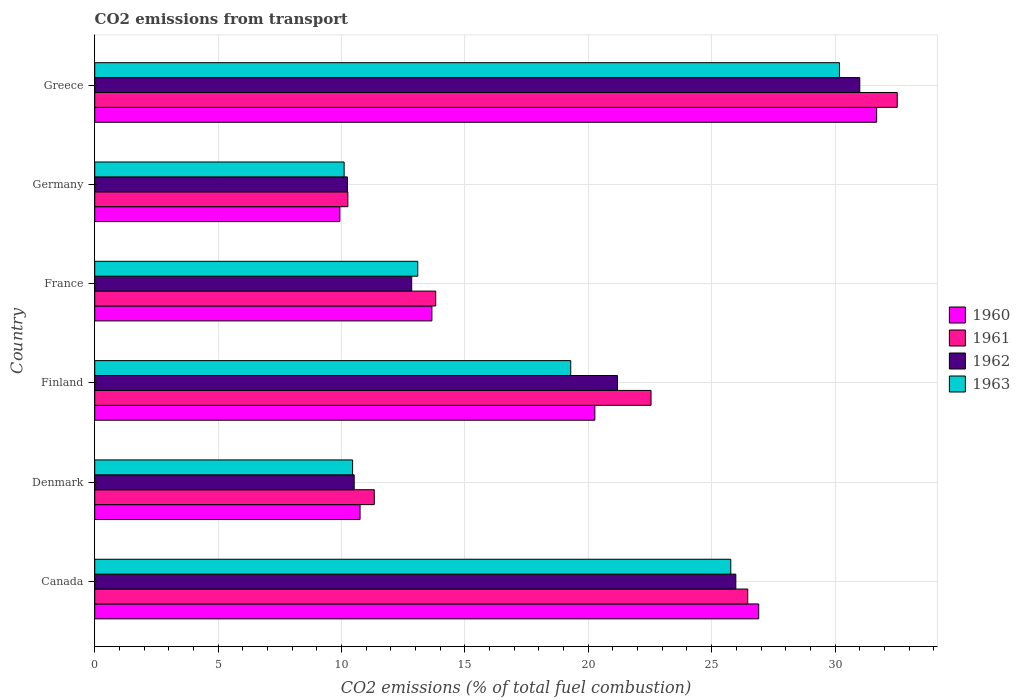How many groups of bars are there?
Your answer should be compact. 6. Are the number of bars per tick equal to the number of legend labels?
Make the answer very short. Yes. How many bars are there on the 6th tick from the top?
Keep it short and to the point. 4. How many bars are there on the 5th tick from the bottom?
Provide a short and direct response. 4. What is the label of the 5th group of bars from the top?
Your answer should be very brief. Denmark. In how many cases, is the number of bars for a given country not equal to the number of legend labels?
Keep it short and to the point. 0. What is the total CO2 emitted in 1962 in France?
Provide a succinct answer. 12.84. Across all countries, what is the maximum total CO2 emitted in 1960?
Provide a succinct answer. 31.69. Across all countries, what is the minimum total CO2 emitted in 1963?
Ensure brevity in your answer.  10.11. In which country was the total CO2 emitted in 1960 maximum?
Offer a very short reply. Greece. In which country was the total CO2 emitted in 1963 minimum?
Provide a short and direct response. Germany. What is the total total CO2 emitted in 1961 in the graph?
Provide a succinct answer. 116.93. What is the difference between the total CO2 emitted in 1963 in France and that in Germany?
Your answer should be very brief. 2.98. What is the difference between the total CO2 emitted in 1963 in France and the total CO2 emitted in 1960 in Denmark?
Make the answer very short. 2.34. What is the average total CO2 emitted in 1963 per country?
Make the answer very short. 18.15. What is the difference between the total CO2 emitted in 1961 and total CO2 emitted in 1960 in Finland?
Your answer should be very brief. 2.28. What is the ratio of the total CO2 emitted in 1963 in Denmark to that in France?
Give a very brief answer. 0.8. Is the total CO2 emitted in 1960 in Finland less than that in Germany?
Ensure brevity in your answer.  No. Is the difference between the total CO2 emitted in 1961 in Denmark and Finland greater than the difference between the total CO2 emitted in 1960 in Denmark and Finland?
Offer a terse response. No. What is the difference between the highest and the second highest total CO2 emitted in 1960?
Offer a terse response. 4.78. What is the difference between the highest and the lowest total CO2 emitted in 1963?
Provide a succinct answer. 20.07. Is it the case that in every country, the sum of the total CO2 emitted in 1963 and total CO2 emitted in 1961 is greater than the total CO2 emitted in 1960?
Your answer should be very brief. Yes. How many bars are there?
Your answer should be compact. 24. Are all the bars in the graph horizontal?
Your response must be concise. Yes. Are the values on the major ticks of X-axis written in scientific E-notation?
Your answer should be compact. No. Does the graph contain any zero values?
Provide a succinct answer. No. Does the graph contain grids?
Offer a terse response. Yes. Where does the legend appear in the graph?
Keep it short and to the point. Center right. How many legend labels are there?
Provide a short and direct response. 4. How are the legend labels stacked?
Give a very brief answer. Vertical. What is the title of the graph?
Your answer should be very brief. CO2 emissions from transport. Does "1982" appear as one of the legend labels in the graph?
Give a very brief answer. No. What is the label or title of the X-axis?
Offer a very short reply. CO2 emissions (% of total fuel combustion). What is the label or title of the Y-axis?
Give a very brief answer. Country. What is the CO2 emissions (% of total fuel combustion) in 1960 in Canada?
Offer a terse response. 26.91. What is the CO2 emissions (% of total fuel combustion) of 1961 in Canada?
Your response must be concise. 26.46. What is the CO2 emissions (% of total fuel combustion) in 1962 in Canada?
Offer a very short reply. 25.98. What is the CO2 emissions (% of total fuel combustion) of 1963 in Canada?
Give a very brief answer. 25.78. What is the CO2 emissions (% of total fuel combustion) of 1960 in Denmark?
Offer a very short reply. 10.75. What is the CO2 emissions (% of total fuel combustion) in 1961 in Denmark?
Offer a terse response. 11.33. What is the CO2 emissions (% of total fuel combustion) in 1962 in Denmark?
Ensure brevity in your answer.  10.51. What is the CO2 emissions (% of total fuel combustion) in 1963 in Denmark?
Your answer should be very brief. 10.45. What is the CO2 emissions (% of total fuel combustion) of 1960 in Finland?
Provide a succinct answer. 20.27. What is the CO2 emissions (% of total fuel combustion) of 1961 in Finland?
Your answer should be very brief. 22.54. What is the CO2 emissions (% of total fuel combustion) of 1962 in Finland?
Offer a very short reply. 21.18. What is the CO2 emissions (% of total fuel combustion) of 1963 in Finland?
Offer a terse response. 19.29. What is the CO2 emissions (% of total fuel combustion) in 1960 in France?
Your response must be concise. 13.66. What is the CO2 emissions (% of total fuel combustion) of 1961 in France?
Your answer should be compact. 13.82. What is the CO2 emissions (% of total fuel combustion) in 1962 in France?
Keep it short and to the point. 12.84. What is the CO2 emissions (% of total fuel combustion) in 1963 in France?
Your response must be concise. 13.09. What is the CO2 emissions (% of total fuel combustion) of 1960 in Germany?
Ensure brevity in your answer.  9.93. What is the CO2 emissions (% of total fuel combustion) of 1961 in Germany?
Provide a short and direct response. 10.26. What is the CO2 emissions (% of total fuel combustion) of 1962 in Germany?
Offer a very short reply. 10.24. What is the CO2 emissions (% of total fuel combustion) of 1963 in Germany?
Offer a terse response. 10.11. What is the CO2 emissions (% of total fuel combustion) in 1960 in Greece?
Keep it short and to the point. 31.69. What is the CO2 emissions (% of total fuel combustion) in 1961 in Greece?
Provide a short and direct response. 32.52. What is the CO2 emissions (% of total fuel combustion) in 1962 in Greece?
Make the answer very short. 31. What is the CO2 emissions (% of total fuel combustion) of 1963 in Greece?
Give a very brief answer. 30.18. Across all countries, what is the maximum CO2 emissions (% of total fuel combustion) of 1960?
Provide a short and direct response. 31.69. Across all countries, what is the maximum CO2 emissions (% of total fuel combustion) in 1961?
Your answer should be very brief. 32.52. Across all countries, what is the maximum CO2 emissions (% of total fuel combustion) of 1962?
Provide a succinct answer. 31. Across all countries, what is the maximum CO2 emissions (% of total fuel combustion) in 1963?
Offer a very short reply. 30.18. Across all countries, what is the minimum CO2 emissions (% of total fuel combustion) of 1960?
Provide a succinct answer. 9.93. Across all countries, what is the minimum CO2 emissions (% of total fuel combustion) of 1961?
Provide a short and direct response. 10.26. Across all countries, what is the minimum CO2 emissions (% of total fuel combustion) of 1962?
Ensure brevity in your answer.  10.24. Across all countries, what is the minimum CO2 emissions (% of total fuel combustion) of 1963?
Provide a short and direct response. 10.11. What is the total CO2 emissions (% of total fuel combustion) in 1960 in the graph?
Your answer should be very brief. 113.21. What is the total CO2 emissions (% of total fuel combustion) of 1961 in the graph?
Offer a terse response. 116.93. What is the total CO2 emissions (% of total fuel combustion) of 1962 in the graph?
Provide a succinct answer. 111.76. What is the total CO2 emissions (% of total fuel combustion) of 1963 in the graph?
Your answer should be compact. 108.89. What is the difference between the CO2 emissions (% of total fuel combustion) in 1960 in Canada and that in Denmark?
Offer a terse response. 16.16. What is the difference between the CO2 emissions (% of total fuel combustion) in 1961 in Canada and that in Denmark?
Your answer should be compact. 15.13. What is the difference between the CO2 emissions (% of total fuel combustion) in 1962 in Canada and that in Denmark?
Your response must be concise. 15.47. What is the difference between the CO2 emissions (% of total fuel combustion) of 1963 in Canada and that in Denmark?
Your answer should be compact. 15.33. What is the difference between the CO2 emissions (% of total fuel combustion) of 1960 in Canada and that in Finland?
Give a very brief answer. 6.64. What is the difference between the CO2 emissions (% of total fuel combustion) of 1961 in Canada and that in Finland?
Give a very brief answer. 3.92. What is the difference between the CO2 emissions (% of total fuel combustion) in 1962 in Canada and that in Finland?
Offer a very short reply. 4.8. What is the difference between the CO2 emissions (% of total fuel combustion) of 1963 in Canada and that in Finland?
Ensure brevity in your answer.  6.49. What is the difference between the CO2 emissions (% of total fuel combustion) in 1960 in Canada and that in France?
Offer a terse response. 13.24. What is the difference between the CO2 emissions (% of total fuel combustion) in 1961 in Canada and that in France?
Provide a succinct answer. 12.64. What is the difference between the CO2 emissions (% of total fuel combustion) in 1962 in Canada and that in France?
Keep it short and to the point. 13.14. What is the difference between the CO2 emissions (% of total fuel combustion) of 1963 in Canada and that in France?
Make the answer very short. 12.68. What is the difference between the CO2 emissions (% of total fuel combustion) in 1960 in Canada and that in Germany?
Give a very brief answer. 16.97. What is the difference between the CO2 emissions (% of total fuel combustion) of 1961 in Canada and that in Germany?
Offer a terse response. 16.21. What is the difference between the CO2 emissions (% of total fuel combustion) of 1962 in Canada and that in Germany?
Provide a succinct answer. 15.74. What is the difference between the CO2 emissions (% of total fuel combustion) in 1963 in Canada and that in Germany?
Offer a terse response. 15.67. What is the difference between the CO2 emissions (% of total fuel combustion) in 1960 in Canada and that in Greece?
Give a very brief answer. -4.78. What is the difference between the CO2 emissions (% of total fuel combustion) of 1961 in Canada and that in Greece?
Offer a very short reply. -6.06. What is the difference between the CO2 emissions (% of total fuel combustion) in 1962 in Canada and that in Greece?
Your answer should be compact. -5.02. What is the difference between the CO2 emissions (% of total fuel combustion) in 1963 in Canada and that in Greece?
Your answer should be very brief. -4.4. What is the difference between the CO2 emissions (% of total fuel combustion) of 1960 in Denmark and that in Finland?
Your answer should be very brief. -9.51. What is the difference between the CO2 emissions (% of total fuel combustion) of 1961 in Denmark and that in Finland?
Keep it short and to the point. -11.22. What is the difference between the CO2 emissions (% of total fuel combustion) in 1962 in Denmark and that in Finland?
Ensure brevity in your answer.  -10.67. What is the difference between the CO2 emissions (% of total fuel combustion) of 1963 in Denmark and that in Finland?
Make the answer very short. -8.84. What is the difference between the CO2 emissions (% of total fuel combustion) of 1960 in Denmark and that in France?
Give a very brief answer. -2.91. What is the difference between the CO2 emissions (% of total fuel combustion) in 1961 in Denmark and that in France?
Keep it short and to the point. -2.49. What is the difference between the CO2 emissions (% of total fuel combustion) of 1962 in Denmark and that in France?
Ensure brevity in your answer.  -2.33. What is the difference between the CO2 emissions (% of total fuel combustion) in 1963 in Denmark and that in France?
Your response must be concise. -2.64. What is the difference between the CO2 emissions (% of total fuel combustion) in 1960 in Denmark and that in Germany?
Give a very brief answer. 0.82. What is the difference between the CO2 emissions (% of total fuel combustion) in 1961 in Denmark and that in Germany?
Offer a very short reply. 1.07. What is the difference between the CO2 emissions (% of total fuel combustion) in 1962 in Denmark and that in Germany?
Give a very brief answer. 0.28. What is the difference between the CO2 emissions (% of total fuel combustion) in 1963 in Denmark and that in Germany?
Your answer should be very brief. 0.34. What is the difference between the CO2 emissions (% of total fuel combustion) of 1960 in Denmark and that in Greece?
Provide a short and direct response. -20.93. What is the difference between the CO2 emissions (% of total fuel combustion) of 1961 in Denmark and that in Greece?
Your answer should be compact. -21.19. What is the difference between the CO2 emissions (% of total fuel combustion) in 1962 in Denmark and that in Greece?
Offer a very short reply. -20.49. What is the difference between the CO2 emissions (% of total fuel combustion) of 1963 in Denmark and that in Greece?
Ensure brevity in your answer.  -19.73. What is the difference between the CO2 emissions (% of total fuel combustion) in 1960 in Finland and that in France?
Keep it short and to the point. 6.6. What is the difference between the CO2 emissions (% of total fuel combustion) in 1961 in Finland and that in France?
Offer a terse response. 8.73. What is the difference between the CO2 emissions (% of total fuel combustion) in 1962 in Finland and that in France?
Your answer should be very brief. 8.34. What is the difference between the CO2 emissions (% of total fuel combustion) in 1963 in Finland and that in France?
Offer a terse response. 6.2. What is the difference between the CO2 emissions (% of total fuel combustion) in 1960 in Finland and that in Germany?
Provide a succinct answer. 10.33. What is the difference between the CO2 emissions (% of total fuel combustion) of 1961 in Finland and that in Germany?
Your answer should be very brief. 12.29. What is the difference between the CO2 emissions (% of total fuel combustion) of 1962 in Finland and that in Germany?
Ensure brevity in your answer.  10.94. What is the difference between the CO2 emissions (% of total fuel combustion) in 1963 in Finland and that in Germany?
Provide a short and direct response. 9.18. What is the difference between the CO2 emissions (% of total fuel combustion) in 1960 in Finland and that in Greece?
Your answer should be compact. -11.42. What is the difference between the CO2 emissions (% of total fuel combustion) of 1961 in Finland and that in Greece?
Give a very brief answer. -9.98. What is the difference between the CO2 emissions (% of total fuel combustion) in 1962 in Finland and that in Greece?
Make the answer very short. -9.82. What is the difference between the CO2 emissions (% of total fuel combustion) of 1963 in Finland and that in Greece?
Offer a terse response. -10.89. What is the difference between the CO2 emissions (% of total fuel combustion) in 1960 in France and that in Germany?
Offer a terse response. 3.73. What is the difference between the CO2 emissions (% of total fuel combustion) of 1961 in France and that in Germany?
Your answer should be very brief. 3.56. What is the difference between the CO2 emissions (% of total fuel combustion) of 1962 in France and that in Germany?
Make the answer very short. 2.6. What is the difference between the CO2 emissions (% of total fuel combustion) in 1963 in France and that in Germany?
Offer a very short reply. 2.98. What is the difference between the CO2 emissions (% of total fuel combustion) in 1960 in France and that in Greece?
Give a very brief answer. -18.02. What is the difference between the CO2 emissions (% of total fuel combustion) in 1961 in France and that in Greece?
Keep it short and to the point. -18.7. What is the difference between the CO2 emissions (% of total fuel combustion) in 1962 in France and that in Greece?
Make the answer very short. -18.16. What is the difference between the CO2 emissions (% of total fuel combustion) in 1963 in France and that in Greece?
Provide a succinct answer. -17.09. What is the difference between the CO2 emissions (% of total fuel combustion) of 1960 in Germany and that in Greece?
Offer a very short reply. -21.75. What is the difference between the CO2 emissions (% of total fuel combustion) of 1961 in Germany and that in Greece?
Your answer should be very brief. -22.26. What is the difference between the CO2 emissions (% of total fuel combustion) in 1962 in Germany and that in Greece?
Keep it short and to the point. -20.76. What is the difference between the CO2 emissions (% of total fuel combustion) in 1963 in Germany and that in Greece?
Provide a succinct answer. -20.07. What is the difference between the CO2 emissions (% of total fuel combustion) of 1960 in Canada and the CO2 emissions (% of total fuel combustion) of 1961 in Denmark?
Offer a very short reply. 15.58. What is the difference between the CO2 emissions (% of total fuel combustion) of 1960 in Canada and the CO2 emissions (% of total fuel combustion) of 1962 in Denmark?
Make the answer very short. 16.39. What is the difference between the CO2 emissions (% of total fuel combustion) in 1960 in Canada and the CO2 emissions (% of total fuel combustion) in 1963 in Denmark?
Your response must be concise. 16.46. What is the difference between the CO2 emissions (% of total fuel combustion) in 1961 in Canada and the CO2 emissions (% of total fuel combustion) in 1962 in Denmark?
Your answer should be very brief. 15.95. What is the difference between the CO2 emissions (% of total fuel combustion) of 1961 in Canada and the CO2 emissions (% of total fuel combustion) of 1963 in Denmark?
Make the answer very short. 16.01. What is the difference between the CO2 emissions (% of total fuel combustion) of 1962 in Canada and the CO2 emissions (% of total fuel combustion) of 1963 in Denmark?
Your response must be concise. 15.53. What is the difference between the CO2 emissions (% of total fuel combustion) in 1960 in Canada and the CO2 emissions (% of total fuel combustion) in 1961 in Finland?
Your response must be concise. 4.36. What is the difference between the CO2 emissions (% of total fuel combustion) in 1960 in Canada and the CO2 emissions (% of total fuel combustion) in 1962 in Finland?
Keep it short and to the point. 5.73. What is the difference between the CO2 emissions (% of total fuel combustion) in 1960 in Canada and the CO2 emissions (% of total fuel combustion) in 1963 in Finland?
Give a very brief answer. 7.62. What is the difference between the CO2 emissions (% of total fuel combustion) in 1961 in Canada and the CO2 emissions (% of total fuel combustion) in 1962 in Finland?
Your answer should be compact. 5.28. What is the difference between the CO2 emissions (% of total fuel combustion) in 1961 in Canada and the CO2 emissions (% of total fuel combustion) in 1963 in Finland?
Provide a short and direct response. 7.17. What is the difference between the CO2 emissions (% of total fuel combustion) in 1962 in Canada and the CO2 emissions (% of total fuel combustion) in 1963 in Finland?
Make the answer very short. 6.69. What is the difference between the CO2 emissions (% of total fuel combustion) of 1960 in Canada and the CO2 emissions (% of total fuel combustion) of 1961 in France?
Give a very brief answer. 13.09. What is the difference between the CO2 emissions (% of total fuel combustion) in 1960 in Canada and the CO2 emissions (% of total fuel combustion) in 1962 in France?
Make the answer very short. 14.06. What is the difference between the CO2 emissions (% of total fuel combustion) of 1960 in Canada and the CO2 emissions (% of total fuel combustion) of 1963 in France?
Your response must be concise. 13.82. What is the difference between the CO2 emissions (% of total fuel combustion) of 1961 in Canada and the CO2 emissions (% of total fuel combustion) of 1962 in France?
Offer a terse response. 13.62. What is the difference between the CO2 emissions (% of total fuel combustion) of 1961 in Canada and the CO2 emissions (% of total fuel combustion) of 1963 in France?
Give a very brief answer. 13.37. What is the difference between the CO2 emissions (% of total fuel combustion) of 1962 in Canada and the CO2 emissions (% of total fuel combustion) of 1963 in France?
Keep it short and to the point. 12.89. What is the difference between the CO2 emissions (% of total fuel combustion) of 1960 in Canada and the CO2 emissions (% of total fuel combustion) of 1961 in Germany?
Offer a very short reply. 16.65. What is the difference between the CO2 emissions (% of total fuel combustion) of 1960 in Canada and the CO2 emissions (% of total fuel combustion) of 1962 in Germany?
Your answer should be very brief. 16.67. What is the difference between the CO2 emissions (% of total fuel combustion) in 1960 in Canada and the CO2 emissions (% of total fuel combustion) in 1963 in Germany?
Keep it short and to the point. 16.8. What is the difference between the CO2 emissions (% of total fuel combustion) in 1961 in Canada and the CO2 emissions (% of total fuel combustion) in 1962 in Germany?
Give a very brief answer. 16.22. What is the difference between the CO2 emissions (% of total fuel combustion) in 1961 in Canada and the CO2 emissions (% of total fuel combustion) in 1963 in Germany?
Provide a succinct answer. 16.36. What is the difference between the CO2 emissions (% of total fuel combustion) in 1962 in Canada and the CO2 emissions (% of total fuel combustion) in 1963 in Germany?
Keep it short and to the point. 15.87. What is the difference between the CO2 emissions (% of total fuel combustion) in 1960 in Canada and the CO2 emissions (% of total fuel combustion) in 1961 in Greece?
Your answer should be compact. -5.61. What is the difference between the CO2 emissions (% of total fuel combustion) in 1960 in Canada and the CO2 emissions (% of total fuel combustion) in 1962 in Greece?
Offer a very short reply. -4.1. What is the difference between the CO2 emissions (% of total fuel combustion) in 1960 in Canada and the CO2 emissions (% of total fuel combustion) in 1963 in Greece?
Ensure brevity in your answer.  -3.27. What is the difference between the CO2 emissions (% of total fuel combustion) of 1961 in Canada and the CO2 emissions (% of total fuel combustion) of 1962 in Greece?
Ensure brevity in your answer.  -4.54. What is the difference between the CO2 emissions (% of total fuel combustion) of 1961 in Canada and the CO2 emissions (% of total fuel combustion) of 1963 in Greece?
Your answer should be compact. -3.72. What is the difference between the CO2 emissions (% of total fuel combustion) in 1962 in Canada and the CO2 emissions (% of total fuel combustion) in 1963 in Greece?
Your response must be concise. -4.2. What is the difference between the CO2 emissions (% of total fuel combustion) of 1960 in Denmark and the CO2 emissions (% of total fuel combustion) of 1961 in Finland?
Offer a very short reply. -11.79. What is the difference between the CO2 emissions (% of total fuel combustion) in 1960 in Denmark and the CO2 emissions (% of total fuel combustion) in 1962 in Finland?
Your response must be concise. -10.43. What is the difference between the CO2 emissions (% of total fuel combustion) in 1960 in Denmark and the CO2 emissions (% of total fuel combustion) in 1963 in Finland?
Provide a succinct answer. -8.54. What is the difference between the CO2 emissions (% of total fuel combustion) in 1961 in Denmark and the CO2 emissions (% of total fuel combustion) in 1962 in Finland?
Your answer should be very brief. -9.85. What is the difference between the CO2 emissions (% of total fuel combustion) of 1961 in Denmark and the CO2 emissions (% of total fuel combustion) of 1963 in Finland?
Ensure brevity in your answer.  -7.96. What is the difference between the CO2 emissions (% of total fuel combustion) in 1962 in Denmark and the CO2 emissions (% of total fuel combustion) in 1963 in Finland?
Your answer should be very brief. -8.78. What is the difference between the CO2 emissions (% of total fuel combustion) of 1960 in Denmark and the CO2 emissions (% of total fuel combustion) of 1961 in France?
Your response must be concise. -3.07. What is the difference between the CO2 emissions (% of total fuel combustion) in 1960 in Denmark and the CO2 emissions (% of total fuel combustion) in 1962 in France?
Provide a succinct answer. -2.09. What is the difference between the CO2 emissions (% of total fuel combustion) of 1960 in Denmark and the CO2 emissions (% of total fuel combustion) of 1963 in France?
Give a very brief answer. -2.34. What is the difference between the CO2 emissions (% of total fuel combustion) in 1961 in Denmark and the CO2 emissions (% of total fuel combustion) in 1962 in France?
Your answer should be compact. -1.52. What is the difference between the CO2 emissions (% of total fuel combustion) of 1961 in Denmark and the CO2 emissions (% of total fuel combustion) of 1963 in France?
Provide a succinct answer. -1.76. What is the difference between the CO2 emissions (% of total fuel combustion) of 1962 in Denmark and the CO2 emissions (% of total fuel combustion) of 1963 in France?
Your answer should be very brief. -2.58. What is the difference between the CO2 emissions (% of total fuel combustion) in 1960 in Denmark and the CO2 emissions (% of total fuel combustion) in 1961 in Germany?
Keep it short and to the point. 0.5. What is the difference between the CO2 emissions (% of total fuel combustion) of 1960 in Denmark and the CO2 emissions (% of total fuel combustion) of 1962 in Germany?
Offer a terse response. 0.51. What is the difference between the CO2 emissions (% of total fuel combustion) in 1960 in Denmark and the CO2 emissions (% of total fuel combustion) in 1963 in Germany?
Offer a terse response. 0.65. What is the difference between the CO2 emissions (% of total fuel combustion) of 1961 in Denmark and the CO2 emissions (% of total fuel combustion) of 1962 in Germany?
Ensure brevity in your answer.  1.09. What is the difference between the CO2 emissions (% of total fuel combustion) of 1961 in Denmark and the CO2 emissions (% of total fuel combustion) of 1963 in Germany?
Give a very brief answer. 1.22. What is the difference between the CO2 emissions (% of total fuel combustion) in 1962 in Denmark and the CO2 emissions (% of total fuel combustion) in 1963 in Germany?
Keep it short and to the point. 0.41. What is the difference between the CO2 emissions (% of total fuel combustion) in 1960 in Denmark and the CO2 emissions (% of total fuel combustion) in 1961 in Greece?
Offer a very short reply. -21.77. What is the difference between the CO2 emissions (% of total fuel combustion) in 1960 in Denmark and the CO2 emissions (% of total fuel combustion) in 1962 in Greece?
Keep it short and to the point. -20.25. What is the difference between the CO2 emissions (% of total fuel combustion) of 1960 in Denmark and the CO2 emissions (% of total fuel combustion) of 1963 in Greece?
Your answer should be very brief. -19.43. What is the difference between the CO2 emissions (% of total fuel combustion) of 1961 in Denmark and the CO2 emissions (% of total fuel combustion) of 1962 in Greece?
Give a very brief answer. -19.67. What is the difference between the CO2 emissions (% of total fuel combustion) in 1961 in Denmark and the CO2 emissions (% of total fuel combustion) in 1963 in Greece?
Make the answer very short. -18.85. What is the difference between the CO2 emissions (% of total fuel combustion) in 1962 in Denmark and the CO2 emissions (% of total fuel combustion) in 1963 in Greece?
Your response must be concise. -19.66. What is the difference between the CO2 emissions (% of total fuel combustion) in 1960 in Finland and the CO2 emissions (% of total fuel combustion) in 1961 in France?
Ensure brevity in your answer.  6.45. What is the difference between the CO2 emissions (% of total fuel combustion) of 1960 in Finland and the CO2 emissions (% of total fuel combustion) of 1962 in France?
Offer a terse response. 7.42. What is the difference between the CO2 emissions (% of total fuel combustion) of 1960 in Finland and the CO2 emissions (% of total fuel combustion) of 1963 in France?
Your answer should be very brief. 7.18. What is the difference between the CO2 emissions (% of total fuel combustion) of 1961 in Finland and the CO2 emissions (% of total fuel combustion) of 1962 in France?
Offer a terse response. 9.7. What is the difference between the CO2 emissions (% of total fuel combustion) in 1961 in Finland and the CO2 emissions (% of total fuel combustion) in 1963 in France?
Your response must be concise. 9.45. What is the difference between the CO2 emissions (% of total fuel combustion) of 1962 in Finland and the CO2 emissions (% of total fuel combustion) of 1963 in France?
Offer a very short reply. 8.09. What is the difference between the CO2 emissions (% of total fuel combustion) of 1960 in Finland and the CO2 emissions (% of total fuel combustion) of 1961 in Germany?
Offer a terse response. 10.01. What is the difference between the CO2 emissions (% of total fuel combustion) in 1960 in Finland and the CO2 emissions (% of total fuel combustion) in 1962 in Germany?
Ensure brevity in your answer.  10.03. What is the difference between the CO2 emissions (% of total fuel combustion) of 1960 in Finland and the CO2 emissions (% of total fuel combustion) of 1963 in Germany?
Offer a very short reply. 10.16. What is the difference between the CO2 emissions (% of total fuel combustion) of 1961 in Finland and the CO2 emissions (% of total fuel combustion) of 1962 in Germany?
Give a very brief answer. 12.3. What is the difference between the CO2 emissions (% of total fuel combustion) in 1961 in Finland and the CO2 emissions (% of total fuel combustion) in 1963 in Germany?
Provide a short and direct response. 12.44. What is the difference between the CO2 emissions (% of total fuel combustion) in 1962 in Finland and the CO2 emissions (% of total fuel combustion) in 1963 in Germany?
Give a very brief answer. 11.07. What is the difference between the CO2 emissions (% of total fuel combustion) of 1960 in Finland and the CO2 emissions (% of total fuel combustion) of 1961 in Greece?
Your answer should be compact. -12.25. What is the difference between the CO2 emissions (% of total fuel combustion) of 1960 in Finland and the CO2 emissions (% of total fuel combustion) of 1962 in Greece?
Provide a short and direct response. -10.74. What is the difference between the CO2 emissions (% of total fuel combustion) in 1960 in Finland and the CO2 emissions (% of total fuel combustion) in 1963 in Greece?
Offer a very short reply. -9.91. What is the difference between the CO2 emissions (% of total fuel combustion) in 1961 in Finland and the CO2 emissions (% of total fuel combustion) in 1962 in Greece?
Your answer should be very brief. -8.46. What is the difference between the CO2 emissions (% of total fuel combustion) of 1961 in Finland and the CO2 emissions (% of total fuel combustion) of 1963 in Greece?
Your response must be concise. -7.63. What is the difference between the CO2 emissions (% of total fuel combustion) in 1962 in Finland and the CO2 emissions (% of total fuel combustion) in 1963 in Greece?
Your answer should be very brief. -9. What is the difference between the CO2 emissions (% of total fuel combustion) in 1960 in France and the CO2 emissions (% of total fuel combustion) in 1961 in Germany?
Provide a succinct answer. 3.41. What is the difference between the CO2 emissions (% of total fuel combustion) of 1960 in France and the CO2 emissions (% of total fuel combustion) of 1962 in Germany?
Offer a terse response. 3.42. What is the difference between the CO2 emissions (% of total fuel combustion) in 1960 in France and the CO2 emissions (% of total fuel combustion) in 1963 in Germany?
Your answer should be very brief. 3.56. What is the difference between the CO2 emissions (% of total fuel combustion) of 1961 in France and the CO2 emissions (% of total fuel combustion) of 1962 in Germany?
Your answer should be very brief. 3.58. What is the difference between the CO2 emissions (% of total fuel combustion) of 1961 in France and the CO2 emissions (% of total fuel combustion) of 1963 in Germany?
Your response must be concise. 3.71. What is the difference between the CO2 emissions (% of total fuel combustion) in 1962 in France and the CO2 emissions (% of total fuel combustion) in 1963 in Germany?
Give a very brief answer. 2.74. What is the difference between the CO2 emissions (% of total fuel combustion) of 1960 in France and the CO2 emissions (% of total fuel combustion) of 1961 in Greece?
Offer a terse response. -18.86. What is the difference between the CO2 emissions (% of total fuel combustion) in 1960 in France and the CO2 emissions (% of total fuel combustion) in 1962 in Greece?
Keep it short and to the point. -17.34. What is the difference between the CO2 emissions (% of total fuel combustion) of 1960 in France and the CO2 emissions (% of total fuel combustion) of 1963 in Greece?
Keep it short and to the point. -16.52. What is the difference between the CO2 emissions (% of total fuel combustion) in 1961 in France and the CO2 emissions (% of total fuel combustion) in 1962 in Greece?
Offer a very short reply. -17.18. What is the difference between the CO2 emissions (% of total fuel combustion) of 1961 in France and the CO2 emissions (% of total fuel combustion) of 1963 in Greece?
Give a very brief answer. -16.36. What is the difference between the CO2 emissions (% of total fuel combustion) of 1962 in France and the CO2 emissions (% of total fuel combustion) of 1963 in Greece?
Keep it short and to the point. -17.33. What is the difference between the CO2 emissions (% of total fuel combustion) in 1960 in Germany and the CO2 emissions (% of total fuel combustion) in 1961 in Greece?
Make the answer very short. -22.59. What is the difference between the CO2 emissions (% of total fuel combustion) of 1960 in Germany and the CO2 emissions (% of total fuel combustion) of 1962 in Greece?
Provide a short and direct response. -21.07. What is the difference between the CO2 emissions (% of total fuel combustion) of 1960 in Germany and the CO2 emissions (% of total fuel combustion) of 1963 in Greece?
Offer a very short reply. -20.24. What is the difference between the CO2 emissions (% of total fuel combustion) in 1961 in Germany and the CO2 emissions (% of total fuel combustion) in 1962 in Greece?
Keep it short and to the point. -20.75. What is the difference between the CO2 emissions (% of total fuel combustion) of 1961 in Germany and the CO2 emissions (% of total fuel combustion) of 1963 in Greece?
Keep it short and to the point. -19.92. What is the difference between the CO2 emissions (% of total fuel combustion) of 1962 in Germany and the CO2 emissions (% of total fuel combustion) of 1963 in Greece?
Your answer should be compact. -19.94. What is the average CO2 emissions (% of total fuel combustion) of 1960 per country?
Offer a terse response. 18.87. What is the average CO2 emissions (% of total fuel combustion) of 1961 per country?
Your answer should be compact. 19.49. What is the average CO2 emissions (% of total fuel combustion) of 1962 per country?
Your answer should be very brief. 18.63. What is the average CO2 emissions (% of total fuel combustion) in 1963 per country?
Ensure brevity in your answer.  18.15. What is the difference between the CO2 emissions (% of total fuel combustion) of 1960 and CO2 emissions (% of total fuel combustion) of 1961 in Canada?
Provide a succinct answer. 0.44. What is the difference between the CO2 emissions (% of total fuel combustion) of 1960 and CO2 emissions (% of total fuel combustion) of 1962 in Canada?
Keep it short and to the point. 0.93. What is the difference between the CO2 emissions (% of total fuel combustion) of 1960 and CO2 emissions (% of total fuel combustion) of 1963 in Canada?
Keep it short and to the point. 1.13. What is the difference between the CO2 emissions (% of total fuel combustion) of 1961 and CO2 emissions (% of total fuel combustion) of 1962 in Canada?
Give a very brief answer. 0.48. What is the difference between the CO2 emissions (% of total fuel combustion) in 1961 and CO2 emissions (% of total fuel combustion) in 1963 in Canada?
Your response must be concise. 0.69. What is the difference between the CO2 emissions (% of total fuel combustion) of 1962 and CO2 emissions (% of total fuel combustion) of 1963 in Canada?
Provide a succinct answer. 0.2. What is the difference between the CO2 emissions (% of total fuel combustion) of 1960 and CO2 emissions (% of total fuel combustion) of 1961 in Denmark?
Make the answer very short. -0.58. What is the difference between the CO2 emissions (% of total fuel combustion) in 1960 and CO2 emissions (% of total fuel combustion) in 1962 in Denmark?
Make the answer very short. 0.24. What is the difference between the CO2 emissions (% of total fuel combustion) in 1960 and CO2 emissions (% of total fuel combustion) in 1963 in Denmark?
Your answer should be very brief. 0.3. What is the difference between the CO2 emissions (% of total fuel combustion) of 1961 and CO2 emissions (% of total fuel combustion) of 1962 in Denmark?
Provide a succinct answer. 0.81. What is the difference between the CO2 emissions (% of total fuel combustion) of 1961 and CO2 emissions (% of total fuel combustion) of 1963 in Denmark?
Keep it short and to the point. 0.88. What is the difference between the CO2 emissions (% of total fuel combustion) of 1962 and CO2 emissions (% of total fuel combustion) of 1963 in Denmark?
Offer a terse response. 0.06. What is the difference between the CO2 emissions (% of total fuel combustion) of 1960 and CO2 emissions (% of total fuel combustion) of 1961 in Finland?
Keep it short and to the point. -2.28. What is the difference between the CO2 emissions (% of total fuel combustion) in 1960 and CO2 emissions (% of total fuel combustion) in 1962 in Finland?
Ensure brevity in your answer.  -0.91. What is the difference between the CO2 emissions (% of total fuel combustion) of 1960 and CO2 emissions (% of total fuel combustion) of 1963 in Finland?
Your response must be concise. 0.98. What is the difference between the CO2 emissions (% of total fuel combustion) of 1961 and CO2 emissions (% of total fuel combustion) of 1962 in Finland?
Make the answer very short. 1.36. What is the difference between the CO2 emissions (% of total fuel combustion) of 1961 and CO2 emissions (% of total fuel combustion) of 1963 in Finland?
Your answer should be compact. 3.25. What is the difference between the CO2 emissions (% of total fuel combustion) in 1962 and CO2 emissions (% of total fuel combustion) in 1963 in Finland?
Provide a short and direct response. 1.89. What is the difference between the CO2 emissions (% of total fuel combustion) in 1960 and CO2 emissions (% of total fuel combustion) in 1961 in France?
Give a very brief answer. -0.16. What is the difference between the CO2 emissions (% of total fuel combustion) of 1960 and CO2 emissions (% of total fuel combustion) of 1962 in France?
Provide a succinct answer. 0.82. What is the difference between the CO2 emissions (% of total fuel combustion) in 1960 and CO2 emissions (% of total fuel combustion) in 1963 in France?
Provide a short and direct response. 0.57. What is the difference between the CO2 emissions (% of total fuel combustion) in 1961 and CO2 emissions (% of total fuel combustion) in 1962 in France?
Provide a short and direct response. 0.97. What is the difference between the CO2 emissions (% of total fuel combustion) of 1961 and CO2 emissions (% of total fuel combustion) of 1963 in France?
Ensure brevity in your answer.  0.73. What is the difference between the CO2 emissions (% of total fuel combustion) of 1962 and CO2 emissions (% of total fuel combustion) of 1963 in France?
Your answer should be compact. -0.25. What is the difference between the CO2 emissions (% of total fuel combustion) of 1960 and CO2 emissions (% of total fuel combustion) of 1961 in Germany?
Offer a terse response. -0.32. What is the difference between the CO2 emissions (% of total fuel combustion) in 1960 and CO2 emissions (% of total fuel combustion) in 1962 in Germany?
Your response must be concise. -0.3. What is the difference between the CO2 emissions (% of total fuel combustion) of 1960 and CO2 emissions (% of total fuel combustion) of 1963 in Germany?
Keep it short and to the point. -0.17. What is the difference between the CO2 emissions (% of total fuel combustion) in 1961 and CO2 emissions (% of total fuel combustion) in 1962 in Germany?
Offer a very short reply. 0.02. What is the difference between the CO2 emissions (% of total fuel combustion) of 1961 and CO2 emissions (% of total fuel combustion) of 1963 in Germany?
Provide a succinct answer. 0.15. What is the difference between the CO2 emissions (% of total fuel combustion) in 1962 and CO2 emissions (% of total fuel combustion) in 1963 in Germany?
Provide a succinct answer. 0.13. What is the difference between the CO2 emissions (% of total fuel combustion) of 1960 and CO2 emissions (% of total fuel combustion) of 1961 in Greece?
Make the answer very short. -0.83. What is the difference between the CO2 emissions (% of total fuel combustion) of 1960 and CO2 emissions (% of total fuel combustion) of 1962 in Greece?
Your answer should be compact. 0.68. What is the difference between the CO2 emissions (% of total fuel combustion) of 1960 and CO2 emissions (% of total fuel combustion) of 1963 in Greece?
Your response must be concise. 1.51. What is the difference between the CO2 emissions (% of total fuel combustion) in 1961 and CO2 emissions (% of total fuel combustion) in 1962 in Greece?
Provide a short and direct response. 1.52. What is the difference between the CO2 emissions (% of total fuel combustion) of 1961 and CO2 emissions (% of total fuel combustion) of 1963 in Greece?
Your answer should be very brief. 2.34. What is the difference between the CO2 emissions (% of total fuel combustion) of 1962 and CO2 emissions (% of total fuel combustion) of 1963 in Greece?
Your answer should be very brief. 0.82. What is the ratio of the CO2 emissions (% of total fuel combustion) in 1960 in Canada to that in Denmark?
Keep it short and to the point. 2.5. What is the ratio of the CO2 emissions (% of total fuel combustion) in 1961 in Canada to that in Denmark?
Give a very brief answer. 2.34. What is the ratio of the CO2 emissions (% of total fuel combustion) in 1962 in Canada to that in Denmark?
Give a very brief answer. 2.47. What is the ratio of the CO2 emissions (% of total fuel combustion) in 1963 in Canada to that in Denmark?
Give a very brief answer. 2.47. What is the ratio of the CO2 emissions (% of total fuel combustion) in 1960 in Canada to that in Finland?
Make the answer very short. 1.33. What is the ratio of the CO2 emissions (% of total fuel combustion) in 1961 in Canada to that in Finland?
Ensure brevity in your answer.  1.17. What is the ratio of the CO2 emissions (% of total fuel combustion) of 1962 in Canada to that in Finland?
Provide a short and direct response. 1.23. What is the ratio of the CO2 emissions (% of total fuel combustion) in 1963 in Canada to that in Finland?
Your answer should be very brief. 1.34. What is the ratio of the CO2 emissions (% of total fuel combustion) of 1960 in Canada to that in France?
Ensure brevity in your answer.  1.97. What is the ratio of the CO2 emissions (% of total fuel combustion) in 1961 in Canada to that in France?
Make the answer very short. 1.92. What is the ratio of the CO2 emissions (% of total fuel combustion) in 1962 in Canada to that in France?
Your answer should be very brief. 2.02. What is the ratio of the CO2 emissions (% of total fuel combustion) of 1963 in Canada to that in France?
Provide a succinct answer. 1.97. What is the ratio of the CO2 emissions (% of total fuel combustion) of 1960 in Canada to that in Germany?
Your answer should be compact. 2.71. What is the ratio of the CO2 emissions (% of total fuel combustion) in 1961 in Canada to that in Germany?
Give a very brief answer. 2.58. What is the ratio of the CO2 emissions (% of total fuel combustion) of 1962 in Canada to that in Germany?
Your answer should be very brief. 2.54. What is the ratio of the CO2 emissions (% of total fuel combustion) of 1963 in Canada to that in Germany?
Give a very brief answer. 2.55. What is the ratio of the CO2 emissions (% of total fuel combustion) in 1960 in Canada to that in Greece?
Offer a very short reply. 0.85. What is the ratio of the CO2 emissions (% of total fuel combustion) in 1961 in Canada to that in Greece?
Your answer should be compact. 0.81. What is the ratio of the CO2 emissions (% of total fuel combustion) in 1962 in Canada to that in Greece?
Keep it short and to the point. 0.84. What is the ratio of the CO2 emissions (% of total fuel combustion) of 1963 in Canada to that in Greece?
Give a very brief answer. 0.85. What is the ratio of the CO2 emissions (% of total fuel combustion) of 1960 in Denmark to that in Finland?
Provide a succinct answer. 0.53. What is the ratio of the CO2 emissions (% of total fuel combustion) in 1961 in Denmark to that in Finland?
Make the answer very short. 0.5. What is the ratio of the CO2 emissions (% of total fuel combustion) of 1962 in Denmark to that in Finland?
Your response must be concise. 0.5. What is the ratio of the CO2 emissions (% of total fuel combustion) of 1963 in Denmark to that in Finland?
Offer a very short reply. 0.54. What is the ratio of the CO2 emissions (% of total fuel combustion) in 1960 in Denmark to that in France?
Offer a very short reply. 0.79. What is the ratio of the CO2 emissions (% of total fuel combustion) in 1961 in Denmark to that in France?
Provide a succinct answer. 0.82. What is the ratio of the CO2 emissions (% of total fuel combustion) of 1962 in Denmark to that in France?
Offer a very short reply. 0.82. What is the ratio of the CO2 emissions (% of total fuel combustion) of 1963 in Denmark to that in France?
Offer a terse response. 0.8. What is the ratio of the CO2 emissions (% of total fuel combustion) in 1960 in Denmark to that in Germany?
Make the answer very short. 1.08. What is the ratio of the CO2 emissions (% of total fuel combustion) of 1961 in Denmark to that in Germany?
Your response must be concise. 1.1. What is the ratio of the CO2 emissions (% of total fuel combustion) in 1962 in Denmark to that in Germany?
Offer a very short reply. 1.03. What is the ratio of the CO2 emissions (% of total fuel combustion) of 1963 in Denmark to that in Germany?
Your response must be concise. 1.03. What is the ratio of the CO2 emissions (% of total fuel combustion) of 1960 in Denmark to that in Greece?
Ensure brevity in your answer.  0.34. What is the ratio of the CO2 emissions (% of total fuel combustion) in 1961 in Denmark to that in Greece?
Offer a very short reply. 0.35. What is the ratio of the CO2 emissions (% of total fuel combustion) in 1962 in Denmark to that in Greece?
Make the answer very short. 0.34. What is the ratio of the CO2 emissions (% of total fuel combustion) of 1963 in Denmark to that in Greece?
Your answer should be very brief. 0.35. What is the ratio of the CO2 emissions (% of total fuel combustion) of 1960 in Finland to that in France?
Your answer should be compact. 1.48. What is the ratio of the CO2 emissions (% of total fuel combustion) in 1961 in Finland to that in France?
Ensure brevity in your answer.  1.63. What is the ratio of the CO2 emissions (% of total fuel combustion) in 1962 in Finland to that in France?
Offer a terse response. 1.65. What is the ratio of the CO2 emissions (% of total fuel combustion) in 1963 in Finland to that in France?
Your answer should be very brief. 1.47. What is the ratio of the CO2 emissions (% of total fuel combustion) of 1960 in Finland to that in Germany?
Ensure brevity in your answer.  2.04. What is the ratio of the CO2 emissions (% of total fuel combustion) of 1961 in Finland to that in Germany?
Give a very brief answer. 2.2. What is the ratio of the CO2 emissions (% of total fuel combustion) in 1962 in Finland to that in Germany?
Give a very brief answer. 2.07. What is the ratio of the CO2 emissions (% of total fuel combustion) of 1963 in Finland to that in Germany?
Keep it short and to the point. 1.91. What is the ratio of the CO2 emissions (% of total fuel combustion) of 1960 in Finland to that in Greece?
Provide a short and direct response. 0.64. What is the ratio of the CO2 emissions (% of total fuel combustion) of 1961 in Finland to that in Greece?
Keep it short and to the point. 0.69. What is the ratio of the CO2 emissions (% of total fuel combustion) of 1962 in Finland to that in Greece?
Offer a very short reply. 0.68. What is the ratio of the CO2 emissions (% of total fuel combustion) in 1963 in Finland to that in Greece?
Provide a succinct answer. 0.64. What is the ratio of the CO2 emissions (% of total fuel combustion) in 1960 in France to that in Germany?
Keep it short and to the point. 1.38. What is the ratio of the CO2 emissions (% of total fuel combustion) of 1961 in France to that in Germany?
Make the answer very short. 1.35. What is the ratio of the CO2 emissions (% of total fuel combustion) in 1962 in France to that in Germany?
Your response must be concise. 1.25. What is the ratio of the CO2 emissions (% of total fuel combustion) of 1963 in France to that in Germany?
Your answer should be very brief. 1.3. What is the ratio of the CO2 emissions (% of total fuel combustion) of 1960 in France to that in Greece?
Keep it short and to the point. 0.43. What is the ratio of the CO2 emissions (% of total fuel combustion) of 1961 in France to that in Greece?
Provide a succinct answer. 0.42. What is the ratio of the CO2 emissions (% of total fuel combustion) of 1962 in France to that in Greece?
Ensure brevity in your answer.  0.41. What is the ratio of the CO2 emissions (% of total fuel combustion) of 1963 in France to that in Greece?
Provide a short and direct response. 0.43. What is the ratio of the CO2 emissions (% of total fuel combustion) of 1960 in Germany to that in Greece?
Give a very brief answer. 0.31. What is the ratio of the CO2 emissions (% of total fuel combustion) of 1961 in Germany to that in Greece?
Keep it short and to the point. 0.32. What is the ratio of the CO2 emissions (% of total fuel combustion) in 1962 in Germany to that in Greece?
Offer a terse response. 0.33. What is the ratio of the CO2 emissions (% of total fuel combustion) of 1963 in Germany to that in Greece?
Your answer should be very brief. 0.33. What is the difference between the highest and the second highest CO2 emissions (% of total fuel combustion) of 1960?
Provide a short and direct response. 4.78. What is the difference between the highest and the second highest CO2 emissions (% of total fuel combustion) of 1961?
Offer a terse response. 6.06. What is the difference between the highest and the second highest CO2 emissions (% of total fuel combustion) in 1962?
Offer a very short reply. 5.02. What is the difference between the highest and the second highest CO2 emissions (% of total fuel combustion) in 1963?
Provide a succinct answer. 4.4. What is the difference between the highest and the lowest CO2 emissions (% of total fuel combustion) of 1960?
Provide a succinct answer. 21.75. What is the difference between the highest and the lowest CO2 emissions (% of total fuel combustion) of 1961?
Provide a succinct answer. 22.26. What is the difference between the highest and the lowest CO2 emissions (% of total fuel combustion) of 1962?
Your answer should be very brief. 20.76. What is the difference between the highest and the lowest CO2 emissions (% of total fuel combustion) in 1963?
Offer a terse response. 20.07. 